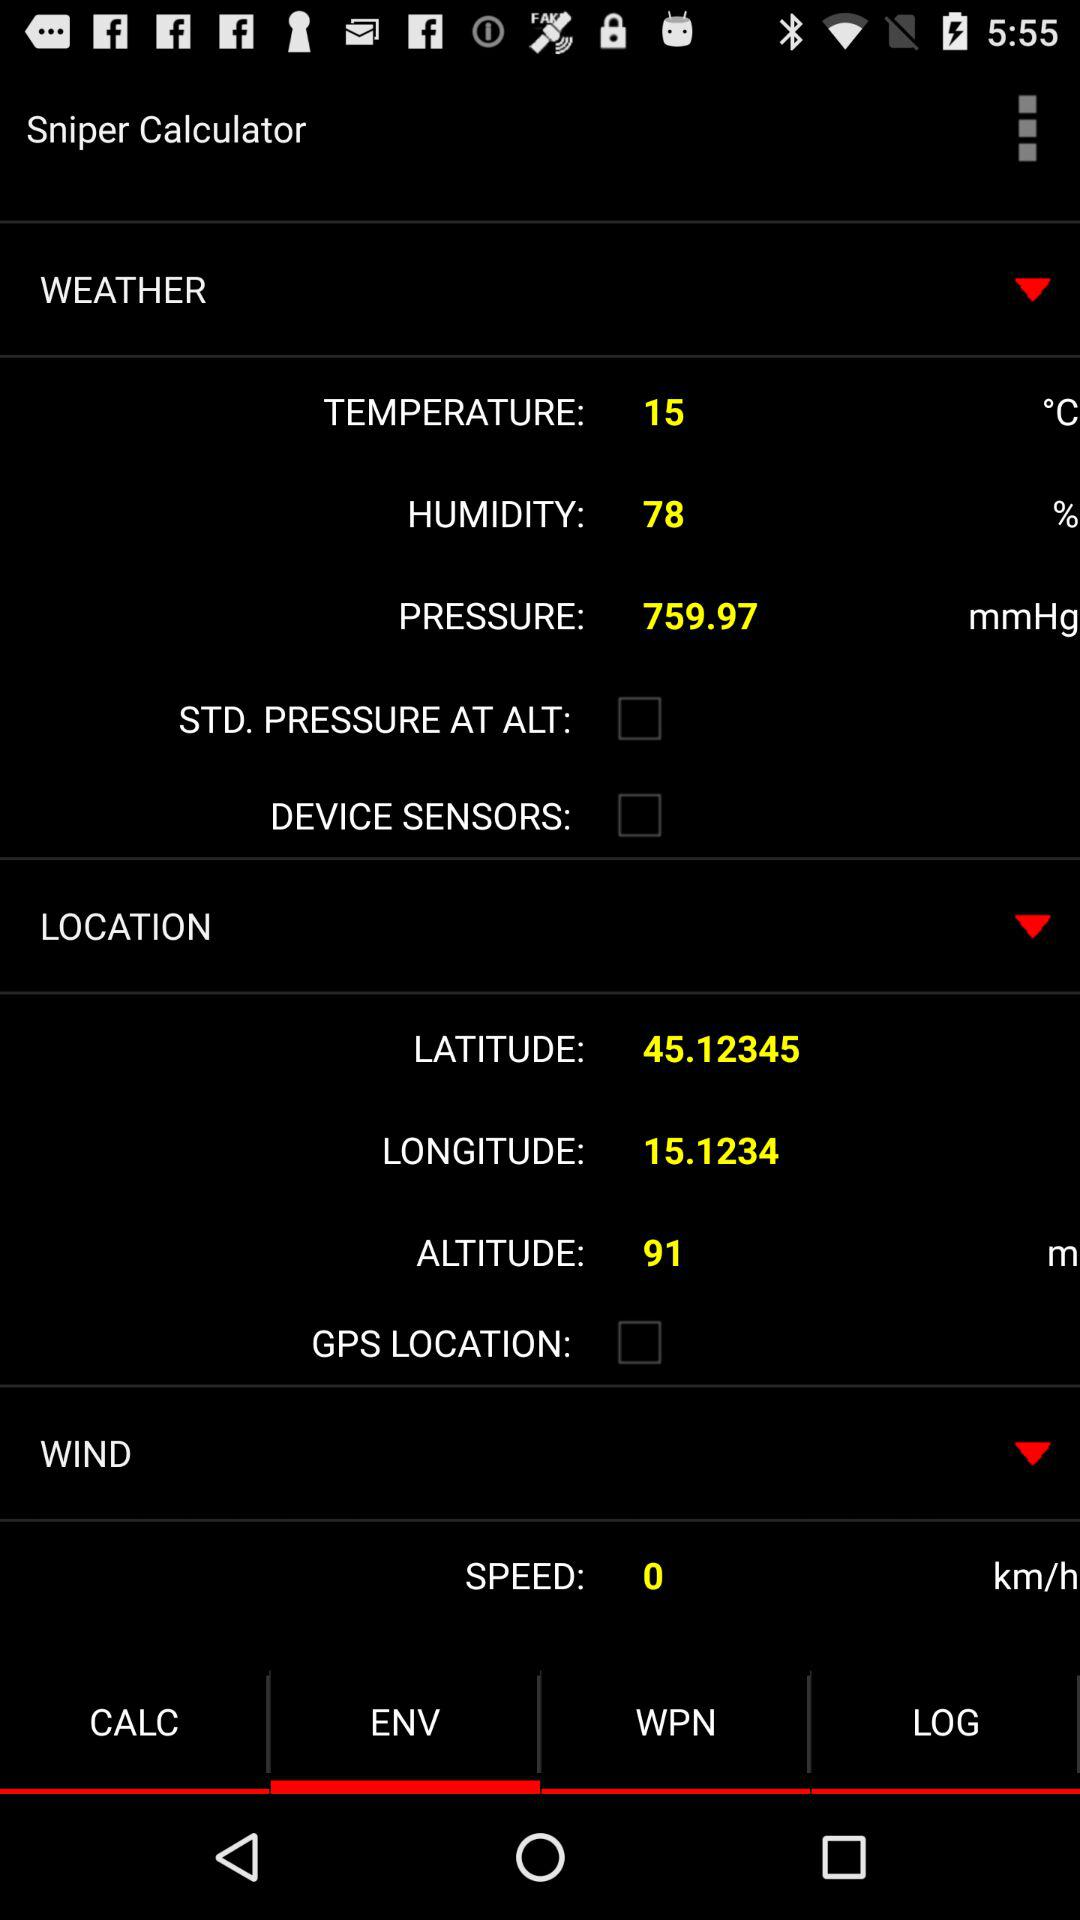What is the status of "DEVICE SENSORS"? The status of "DEVICE SENSORS" is "off". 